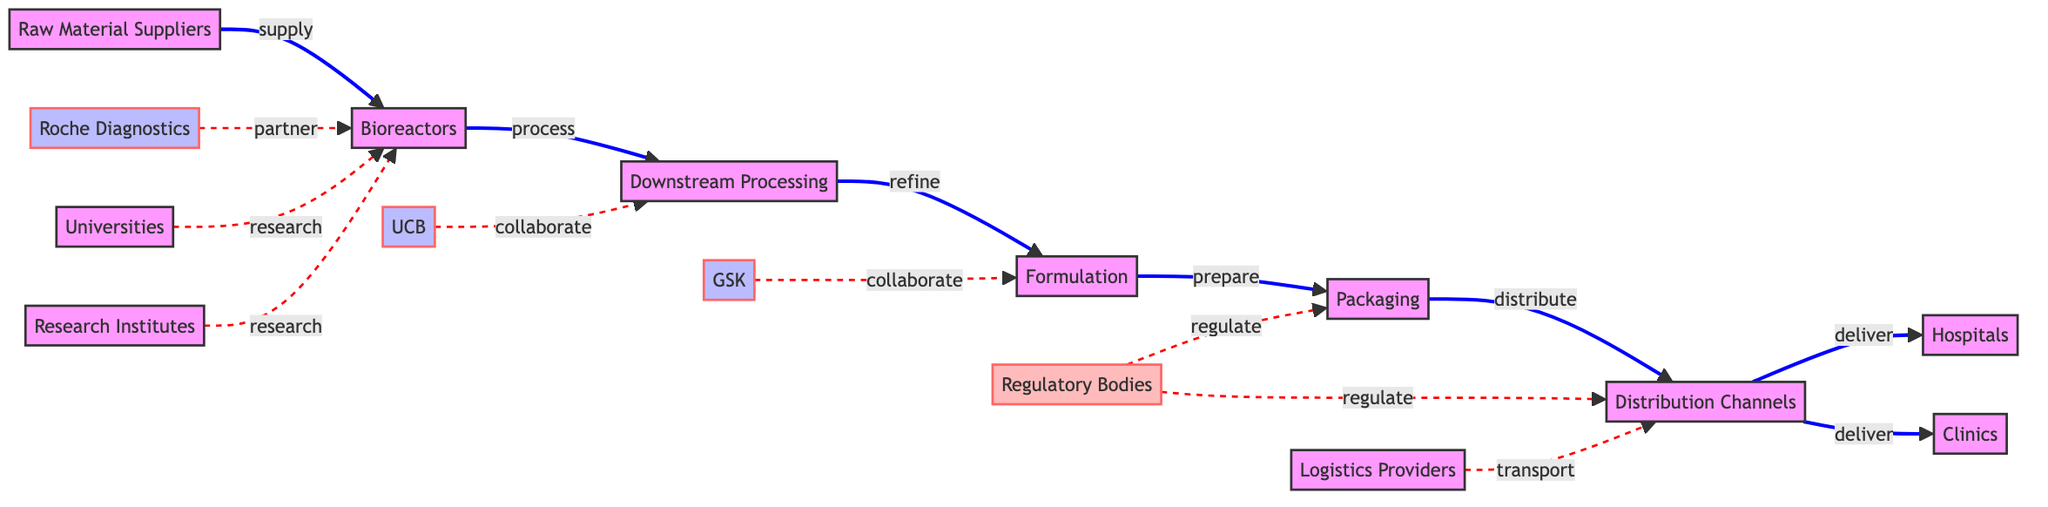What are the main suppliers in biopharmaceutical manufacturing in Belgium? The main suppliers in biopharmaceutical manufacturing are Raw Material Suppliers, as shown at the beginning of the supply chain pathway.
Answer: Raw Material Suppliers How many nodes are present in the diagram? The diagram contains 15 nodes, which represent various elements in the biopharmaceutical supply chain.
Answer: 15 What is the relationship between Bioreactors and Downstream Processing? The relationship between Bioreactors and Downstream Processing is indicated by the directed edge labeled "process," which shows that the product of Bioreactors is processed in Downstream Processing.
Answer: process Which company collaborates with the Formulation step? GSK is the company that collaborates specifically with the Formulation step according to the diagram.
Answer: GSK What do Regulatory Bodies do in relation to Packaging? Regulatory Bodies regulate the Packaging step, as indicated by the dashed line labeled "regulate."
Answer: regulate Which entities are responsible for the transportation of products in the supply chain? The Logistics Providers are responsible for the transportation of products, as shown connecting to Distribution Channels.
Answer: Logistics Providers How many different types of organizations are involved in the biopharmaceutical supply chain according to the diagram? There are six different types of organizations involved, which include suppliers, companies, regulatory bodies, universities, research institutes, and logistics providers.
Answer: 6 What types of establishments receive deliveries from the Distribution Channels? The Distribution Channels deliver to both Hospitals and Clinics, which are the endpoints in the delivery process.
Answer: Hospitals and Clinics Which stages of the supply chain involve collaboration? Both Downstream Processing and Formulation stages involve collaboration, with UCB collaborating with Downstream Processing and GSK collaborating with Formulation.
Answer: Downstream Processing, Formulation 